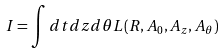<formula> <loc_0><loc_0><loc_500><loc_500>I = \int d t d z d \theta L ( R , A _ { 0 } , A _ { z } , A _ { \theta } )</formula> 